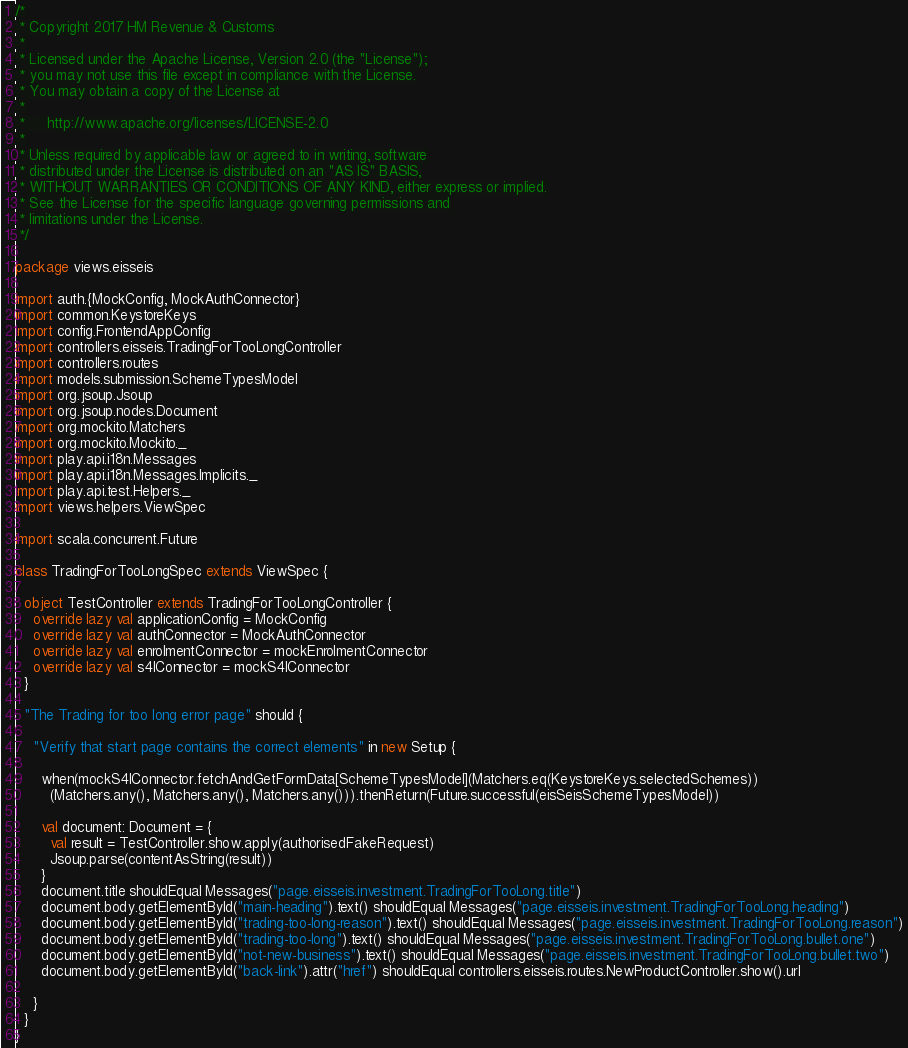Convert code to text. <code><loc_0><loc_0><loc_500><loc_500><_Scala_>/*
 * Copyright 2017 HM Revenue & Customs
 *
 * Licensed under the Apache License, Version 2.0 (the "License");
 * you may not use this file except in compliance with the License.
 * You may obtain a copy of the License at
 *
 *     http://www.apache.org/licenses/LICENSE-2.0
 *
 * Unless required by applicable law or agreed to in writing, software
 * distributed under the License is distributed on an "AS IS" BASIS,
 * WITHOUT WARRANTIES OR CONDITIONS OF ANY KIND, either express or implied.
 * See the License for the specific language governing permissions and
 * limitations under the License.
 */

package views.eisseis

import auth.{MockConfig, MockAuthConnector}
import common.KeystoreKeys
import config.FrontendAppConfig
import controllers.eisseis.TradingForTooLongController
import controllers.routes
import models.submission.SchemeTypesModel
import org.jsoup.Jsoup
import org.jsoup.nodes.Document
import org.mockito.Matchers
import org.mockito.Mockito._
import play.api.i18n.Messages
import play.api.i18n.Messages.Implicits._
import play.api.test.Helpers._
import views.helpers.ViewSpec

import scala.concurrent.Future

class TradingForTooLongSpec extends ViewSpec {

  object TestController extends TradingForTooLongController {
    override lazy val applicationConfig = MockConfig
    override lazy val authConnector = MockAuthConnector
    override lazy val enrolmentConnector = mockEnrolmentConnector
    override lazy val s4lConnector = mockS4lConnector
  }

  "The Trading for too long error page" should {

    "Verify that start page contains the correct elements" in new Setup {

      when(mockS4lConnector.fetchAndGetFormData[SchemeTypesModel](Matchers.eq(KeystoreKeys.selectedSchemes))
        (Matchers.any(), Matchers.any(), Matchers.any())).thenReturn(Future.successful(eisSeisSchemeTypesModel))

      val document: Document = {
        val result = TestController.show.apply(authorisedFakeRequest)
        Jsoup.parse(contentAsString(result))
      }
      document.title shouldEqual Messages("page.eisseis.investment.TradingForTooLong.title")
      document.body.getElementById("main-heading").text() shouldEqual Messages("page.eisseis.investment.TradingForTooLong.heading")
      document.body.getElementById("trading-too-long-reason").text() shouldEqual Messages("page.eisseis.investment.TradingForTooLong.reason")
      document.body.getElementById("trading-too-long").text() shouldEqual Messages("page.eisseis.investment.TradingForTooLong.bullet.one")
      document.body.getElementById("not-new-business").text() shouldEqual Messages("page.eisseis.investment.TradingForTooLong.bullet.two")
      document.body.getElementById("back-link").attr("href") shouldEqual controllers.eisseis.routes.NewProductController.show().url

    }
  }
}
</code> 